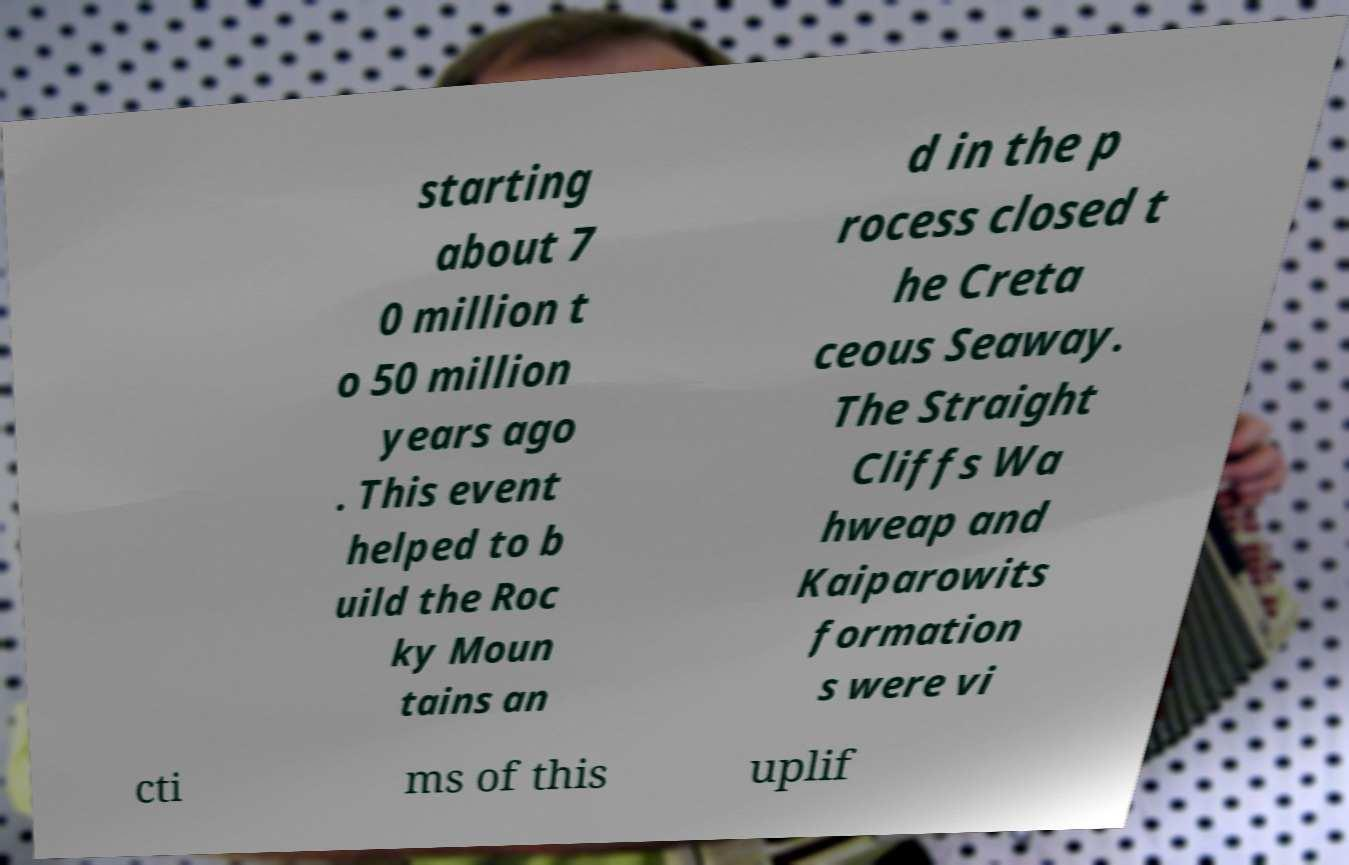For documentation purposes, I need the text within this image transcribed. Could you provide that? starting about 7 0 million t o 50 million years ago . This event helped to b uild the Roc ky Moun tains an d in the p rocess closed t he Creta ceous Seaway. The Straight Cliffs Wa hweap and Kaiparowits formation s were vi cti ms of this uplif 